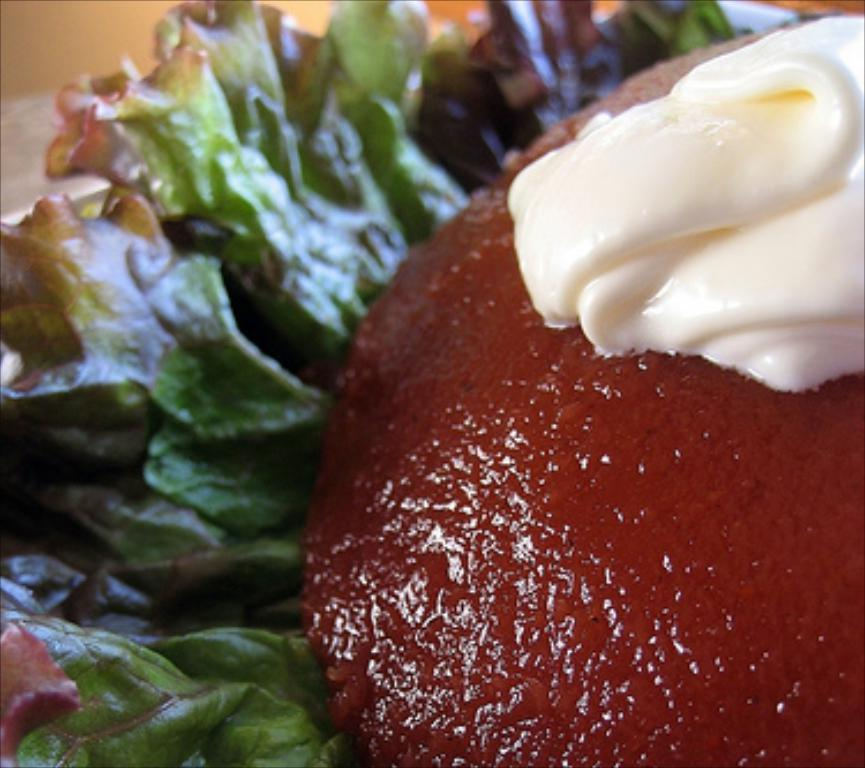What is the main subject of the image? There is a food item in the image. What type of agreement is being signed by the flesh in the image? There is no flesh or agreement present in the image; it only features a food item. 